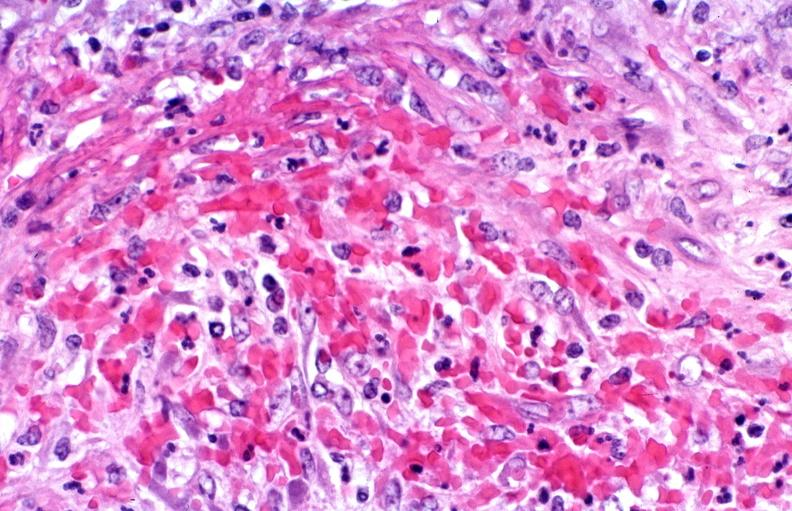where is this from?
Answer the question using a single word or phrase. Vasculature 